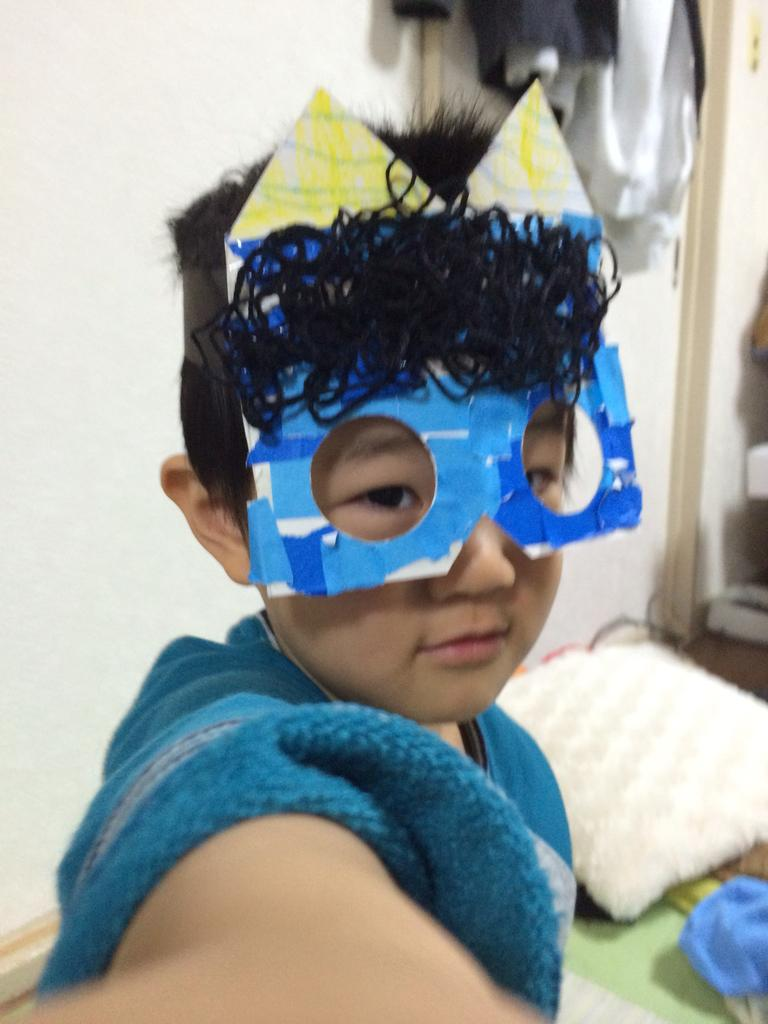Who is present in the image? There is a boy in the image. What is the boy wearing on his face? The boy is wearing a mask. What can be seen on the floor in the image? There is a pillow in the image. What else can be seen in the image besides the boy and the pillow? There are other objects in the image. What is visible in the background of the image? There is a wall and clothes in the background of the image. What type of competition is the boy participating in, as seen in the image? There is no competition visible in the image; it only shows a boy wearing a mask and other objects. Can you tell me how many kettles are present in the image? There are no kettles present in the image. 